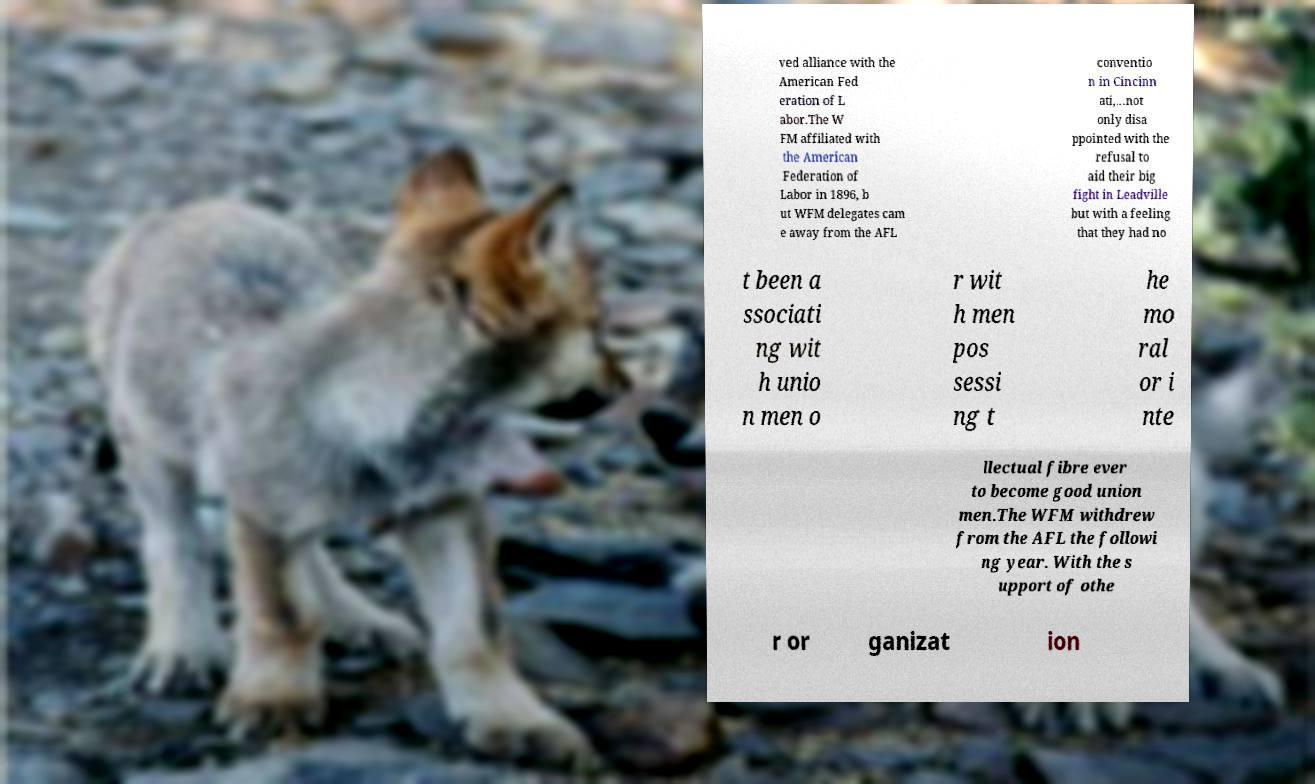Can you read and provide the text displayed in the image?This photo seems to have some interesting text. Can you extract and type it out for me? ved alliance with the American Fed eration of L abor.The W FM affiliated with the American Federation of Labor in 1896, b ut WFM delegates cam e away from the AFL conventio n in Cincinn ati,...not only disa ppointed with the refusal to aid their big fight in Leadville but with a feeling that they had no t been a ssociati ng wit h unio n men o r wit h men pos sessi ng t he mo ral or i nte llectual fibre ever to become good union men.The WFM withdrew from the AFL the followi ng year. With the s upport of othe r or ganizat ion 